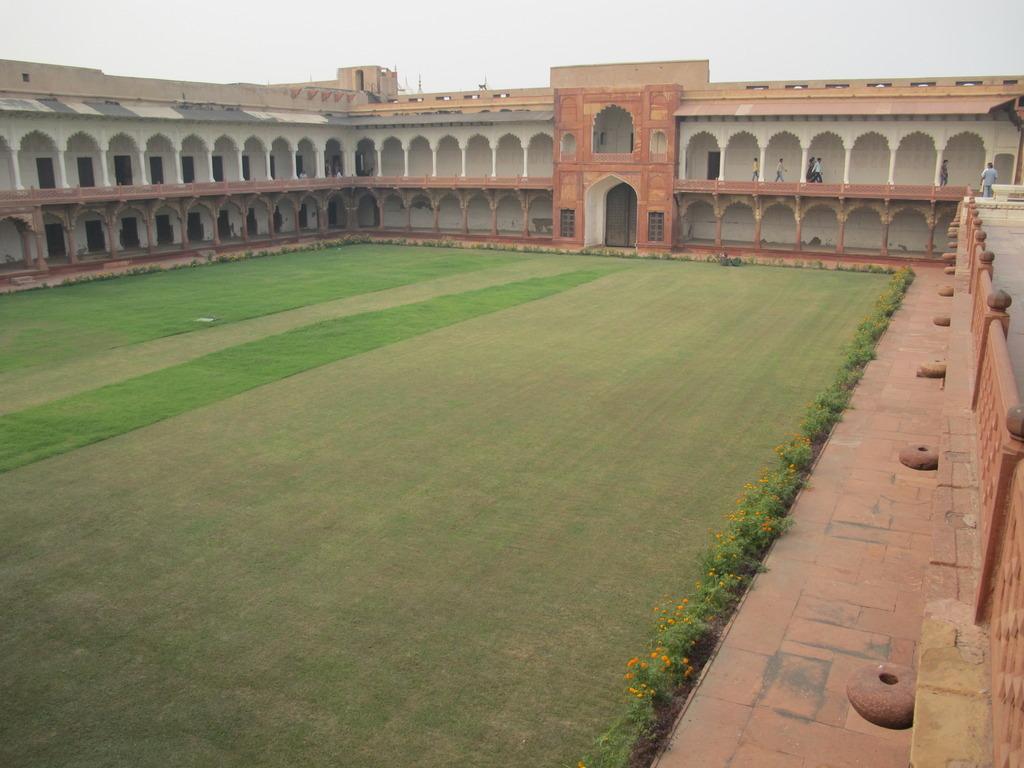Describe this image in one or two sentences. In this image we can see a building with several pillars, windows and a door. We can also see a group of people standing inside the building, some plants with flowers, grass and the sky which looks cloudy. 